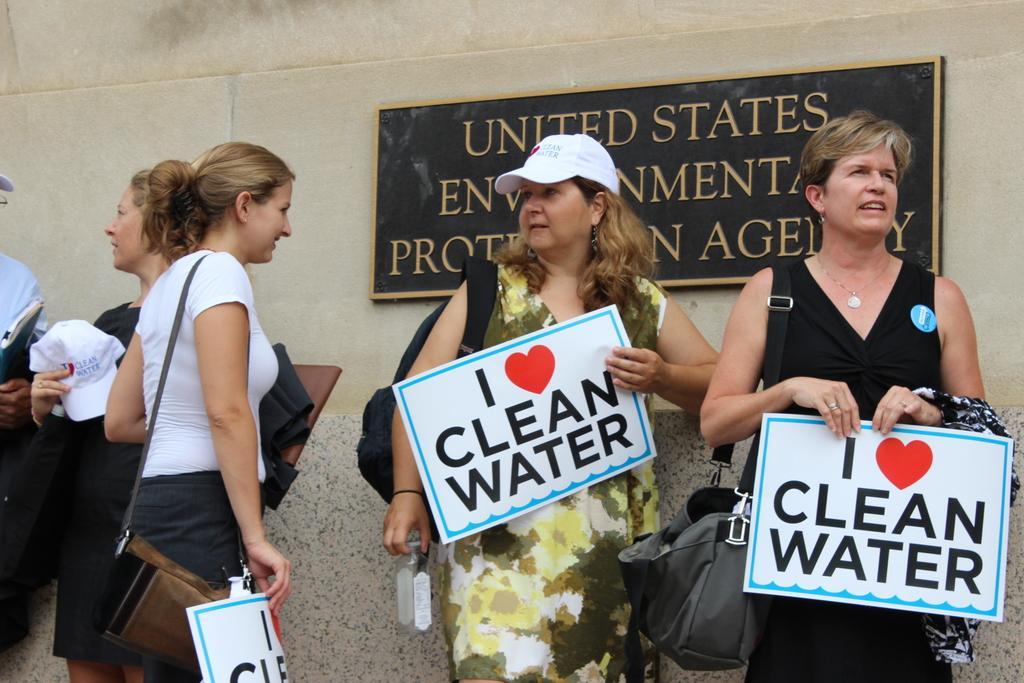Can you describe this image briefly? In this image few women are standing. Behind them there is a wall having a board attached to it. Few women are holding posters in their hands. Middle of the image there is a woman carrying a bag. She is wearing a cap. Left side there is a woman holding a cap. Beside her there is a person holding an object in his hand. 